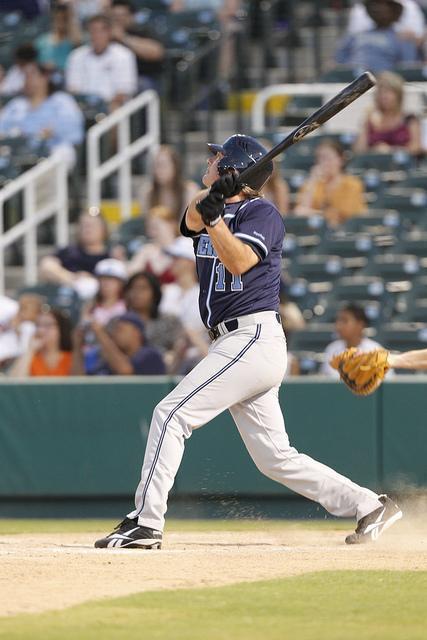How many people are in the picture?
Give a very brief answer. 12. 